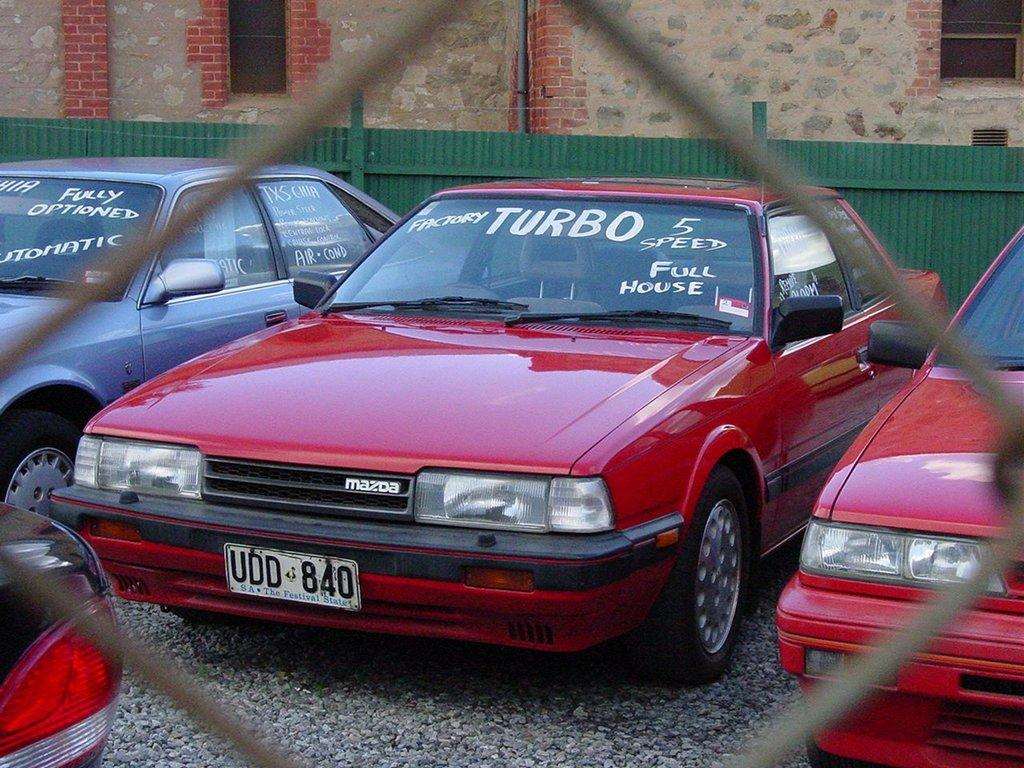How many cars can be seen in the image? There are three or four cars in the image. Where is the first car located in the image? One car is on the left side of the image. Where is the second car located in the image? One car is in the middle of the image. Where is the third car located in the image? One car is on the right side of the image. Where is the fourth car located in the image? One car is in the bottom left corner of the image. What type of lace can be seen on the tires of the cars in the image? There is no lace present on the tires of the cars in the image. What effect does the chalk have on the cars in the image? There is no chalk present in the image, so it cannot have any effect on the cars. 